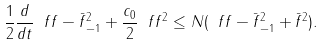Convert formula to latex. <formula><loc_0><loc_0><loc_500><loc_500>\frac { 1 } { 2 } \frac { d } { d t } \| \ f f - \bar { f } \| _ { - 1 } ^ { 2 } + \frac { c _ { 0 } } { 2 } \| \ f f \| ^ { 2 } \leq N ( \| \ f f - \bar { f } \| ^ { 2 } _ { - 1 } + \bar { f } ^ { 2 } ) .</formula> 